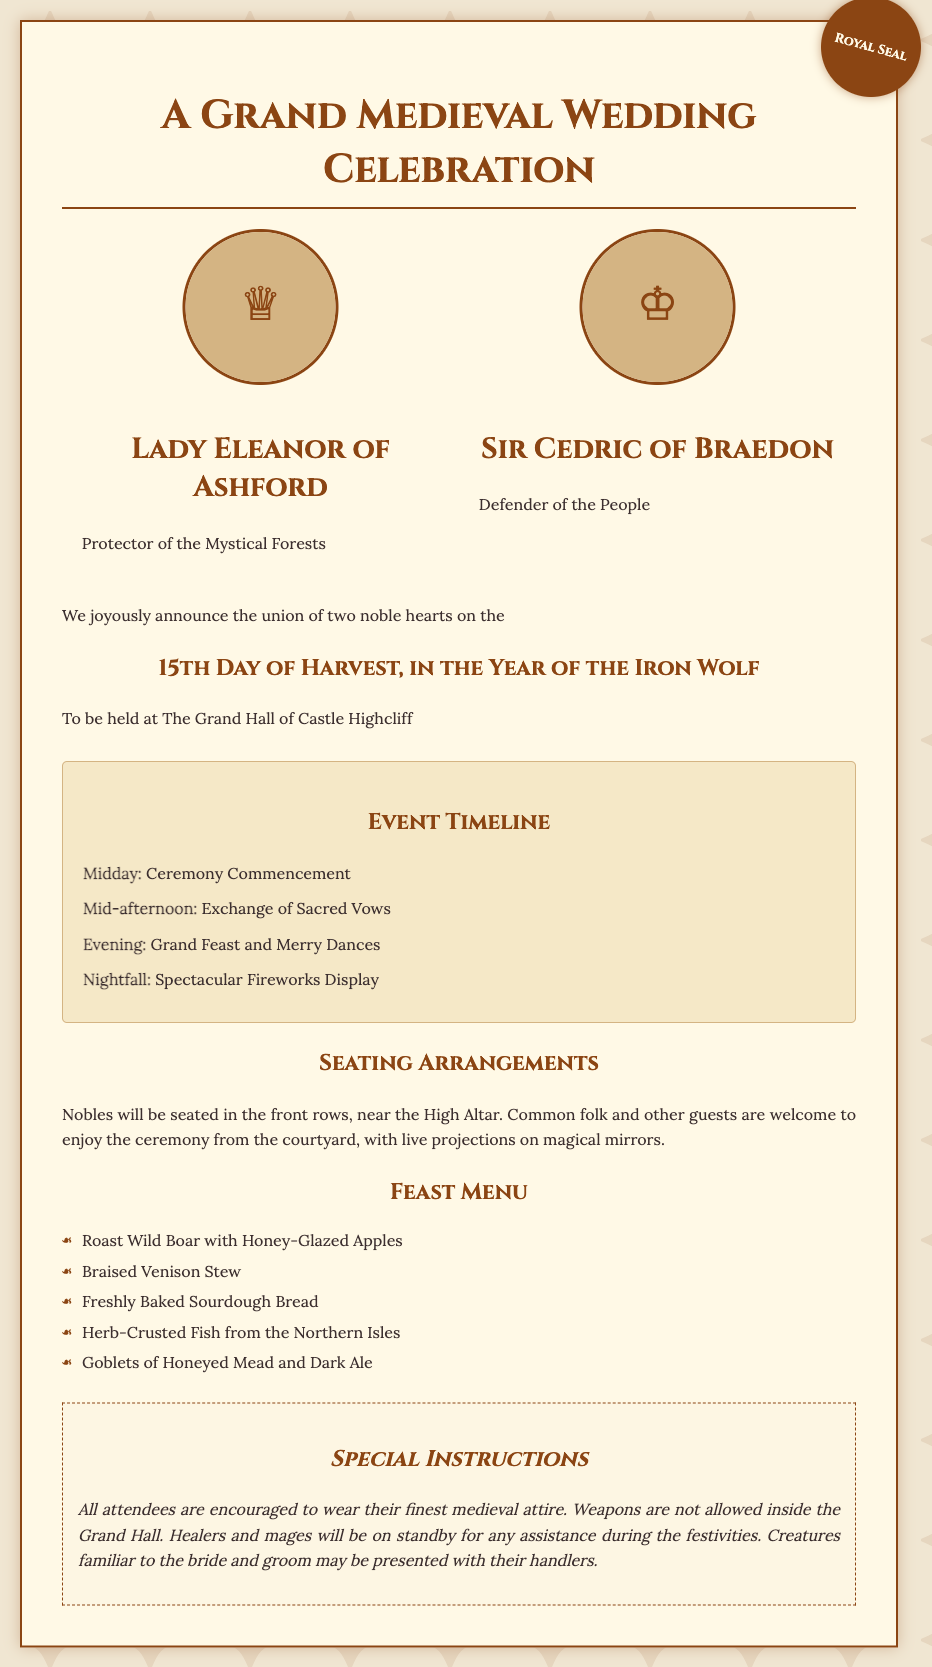What is the date of the wedding? The wedding date is explicitly mentioned in the document as the 15th day of Harvest, in the Year of the Iron Wolf.
Answer: 15th Day of Harvest Where will the ceremony take place? The document states that the ceremony will be held at The Grand Hall of Castle Highcliff.
Answer: The Grand Hall of Castle Highcliff Who is the bride? The document identifies Lady Eleanor as the bride of the wedding ceremony.
Answer: Lady Eleanor of Ashford What time does the ceremony commence? The timeline section indicates that the ceremony commencement is at midday.
Answer: Midday What will happen during the evening? The event timeline mentions that a grand feast and merry dances will occur in the evening.
Answer: Grand Feast and Merry Dances Who is the groom? The document identifies Sir Cedric as the groom of the wedding ceremony.
Answer: Sir Cedric of Braedon Are weapons allowed inside the Grand Hall? The special instructions clearly state that weapons are not allowed inside the Grand Hall.
Answer: No What type of attire is encouraged for attendees? According to the special instructions, attendees are encouraged to wear their finest medieval attire.
Answer: Finest medieval attire Which menu item features fish? The feast menu specifies "Herb-Crusted Fish from the Northern Isles" as the item that features fish.
Answer: Herb-Crusted Fish from the Northern Isles 